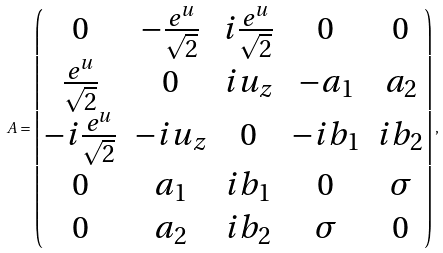Convert formula to latex. <formula><loc_0><loc_0><loc_500><loc_500>A = \begin{pmatrix} 0 & - \frac { e ^ { u } } { \sqrt { 2 } } & i \frac { e ^ { u } } { \sqrt { 2 } } & 0 & 0 \\ \frac { e ^ { u } } { \sqrt { 2 } } & 0 & i u _ { z } & - a _ { 1 } & a _ { 2 } \\ - i \frac { e ^ { u } } { \sqrt { 2 } } & - i u _ { z } & 0 & - i b _ { 1 } & i b _ { 2 } \\ 0 & a _ { 1 } & i b _ { 1 } & 0 & \sigma \\ 0 & a _ { 2 } & i b _ { 2 } & \sigma & 0 \\ \end{pmatrix} ,</formula> 